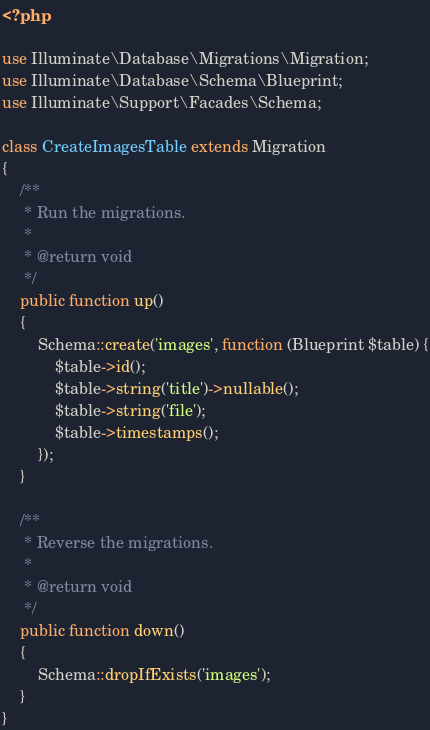Convert code to text. <code><loc_0><loc_0><loc_500><loc_500><_PHP_><?php

use Illuminate\Database\Migrations\Migration;
use Illuminate\Database\Schema\Blueprint;
use Illuminate\Support\Facades\Schema;

class CreateImagesTable extends Migration
{
    /**
     * Run the migrations.
     *
     * @return void
     */
    public function up()
    {
        Schema::create('images', function (Blueprint $table) {
            $table->id();
            $table->string('title')->nullable();
            $table->string('file');
            $table->timestamps();
        });
    }

    /**
     * Reverse the migrations.
     *
     * @return void
     */
    public function down()
    {
        Schema::dropIfExists('images');
    }
}
</code> 